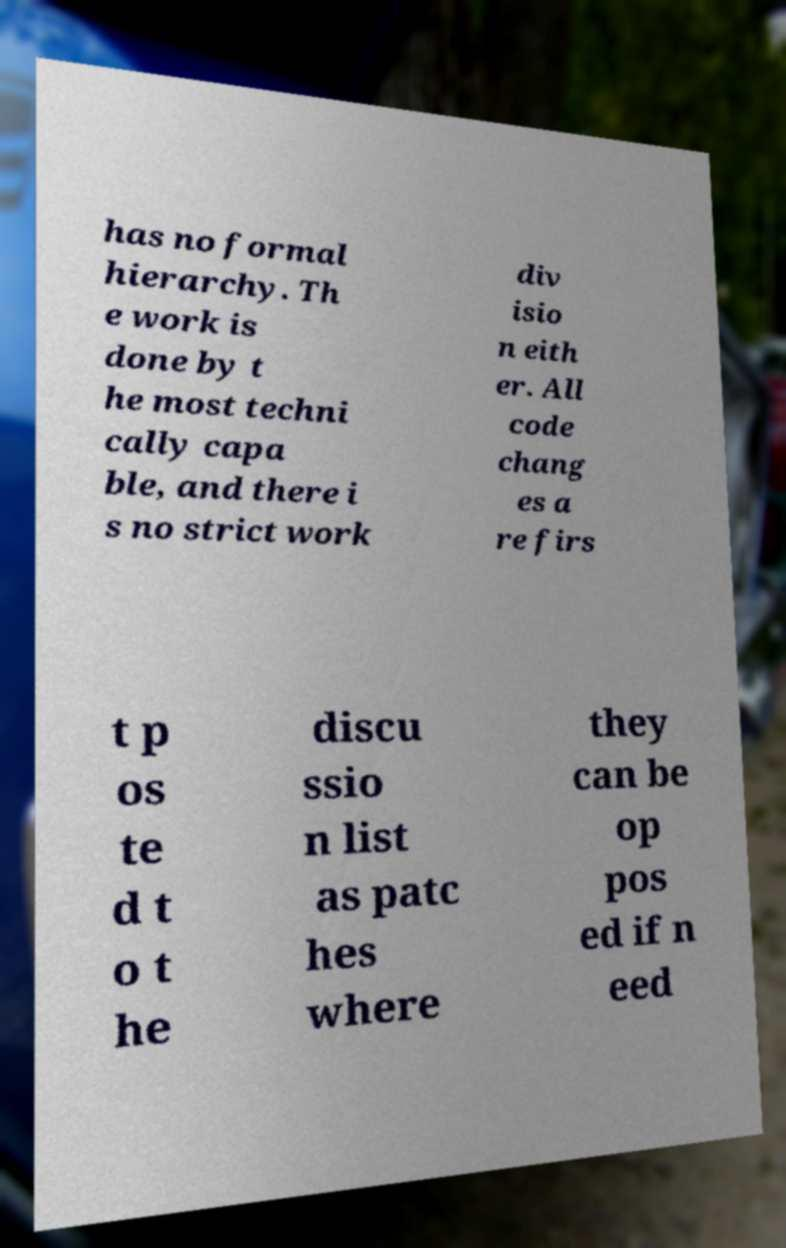Can you accurately transcribe the text from the provided image for me? has no formal hierarchy. Th e work is done by t he most techni cally capa ble, and there i s no strict work div isio n eith er. All code chang es a re firs t p os te d t o t he discu ssio n list as patc hes where they can be op pos ed if n eed 